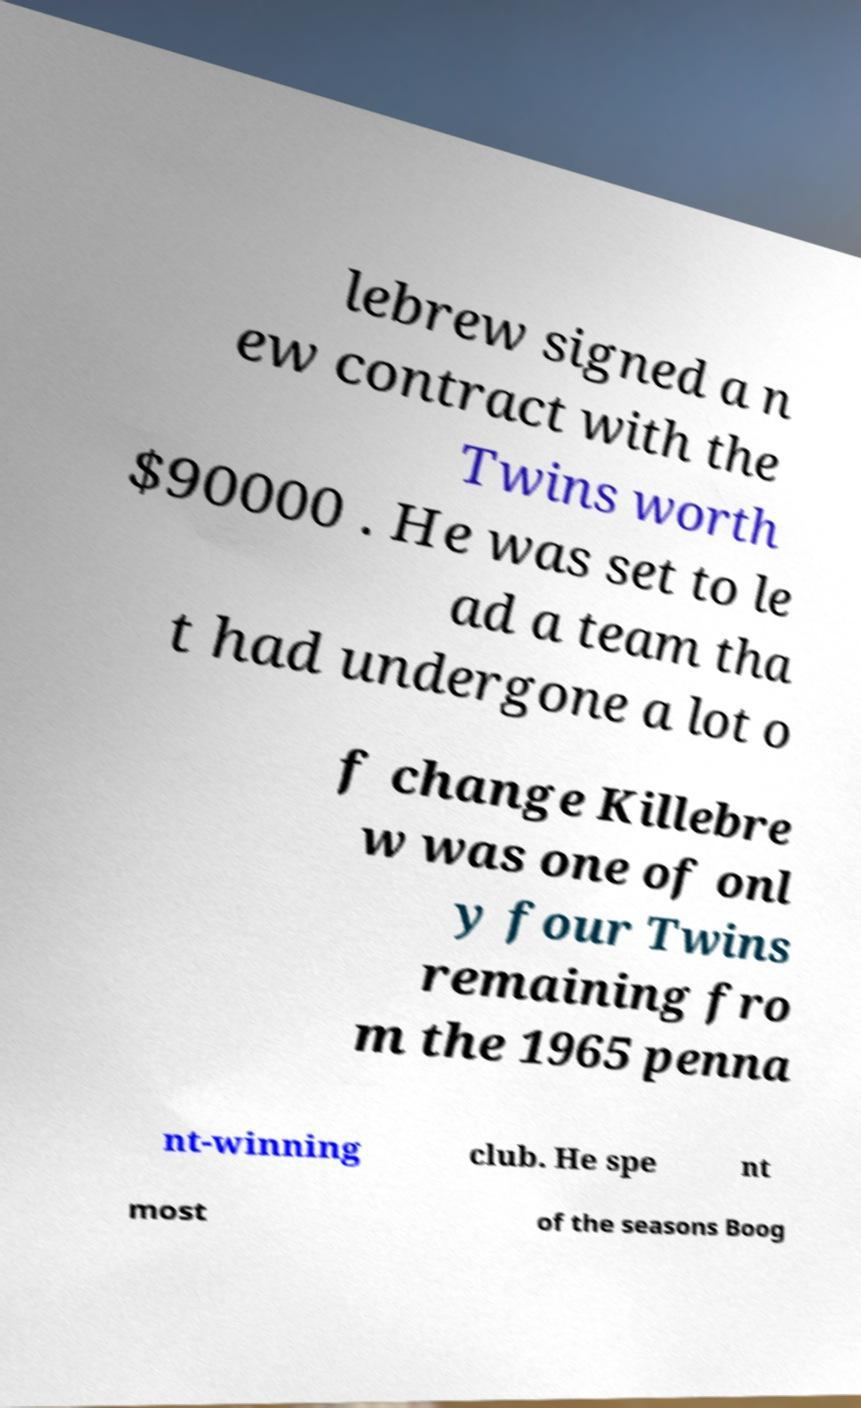Can you accurately transcribe the text from the provided image for me? lebrew signed a n ew contract with the Twins worth $90000 . He was set to le ad a team tha t had undergone a lot o f change Killebre w was one of onl y four Twins remaining fro m the 1965 penna nt-winning club. He spe nt most of the seasons Boog 